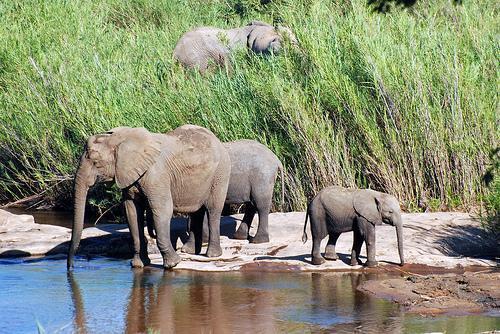How many elephants are facing right?
Give a very brief answer. 1. How many elephants are in the grassy area of the image?
Give a very brief answer. 1. How many elephants are hiding in the grass?
Give a very brief answer. 1. 